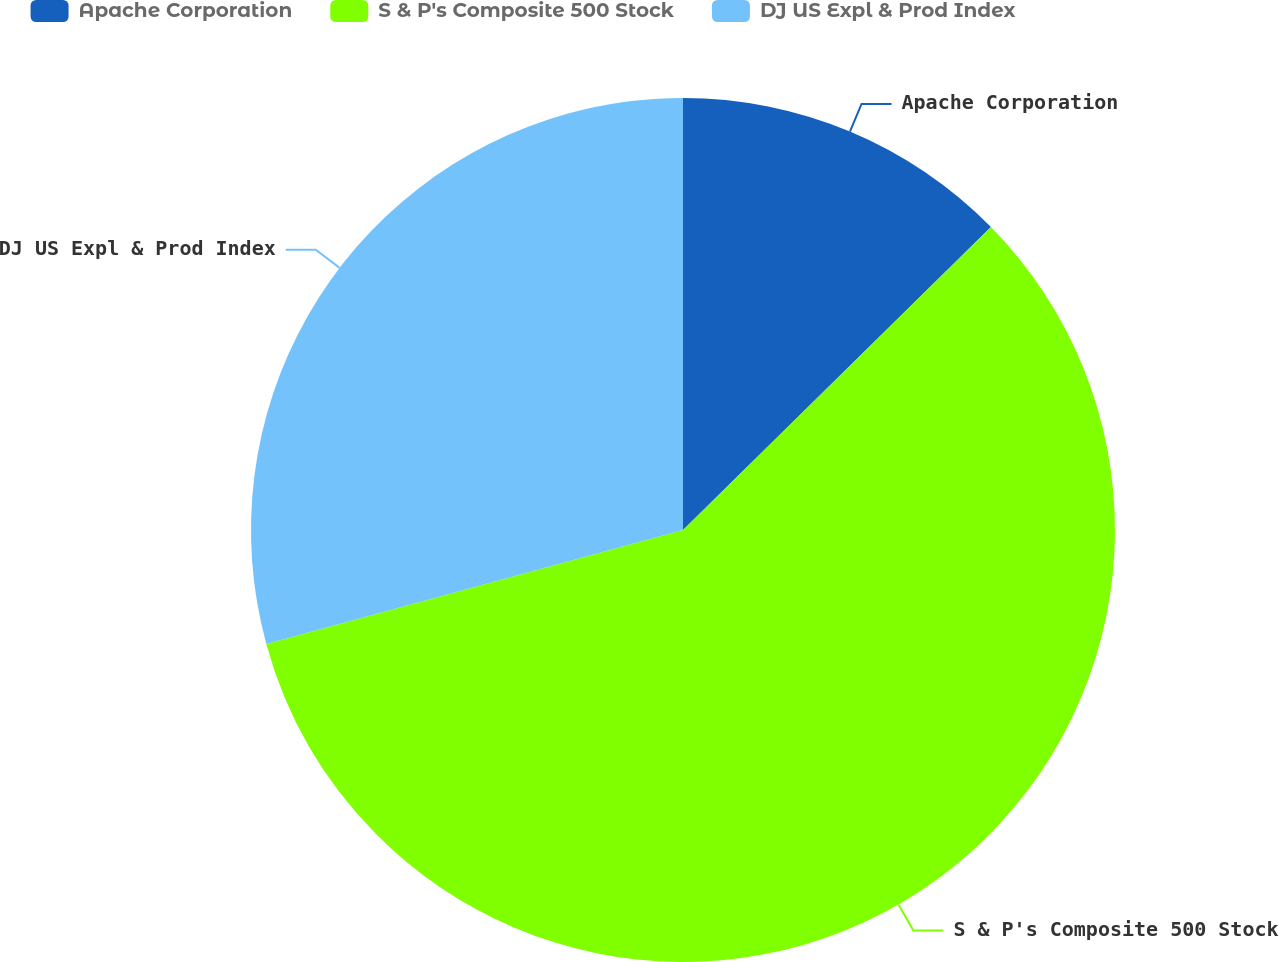Convert chart to OTSL. <chart><loc_0><loc_0><loc_500><loc_500><pie_chart><fcel>Apache Corporation<fcel>S & P's Composite 500 Stock<fcel>DJ US Expl & Prod Index<nl><fcel>12.63%<fcel>58.12%<fcel>29.25%<nl></chart> 